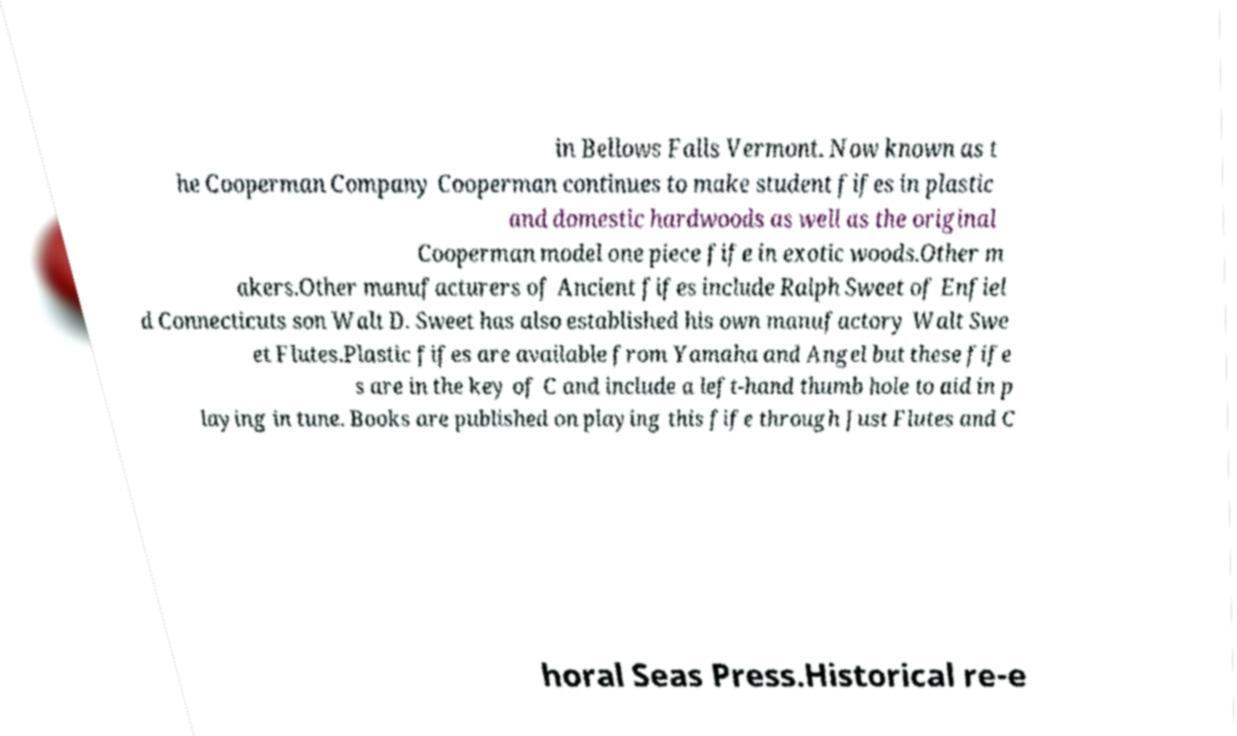What messages or text are displayed in this image? I need them in a readable, typed format. in Bellows Falls Vermont. Now known as t he Cooperman Company Cooperman continues to make student fifes in plastic and domestic hardwoods as well as the original Cooperman model one piece fife in exotic woods.Other m akers.Other manufacturers of Ancient fifes include Ralph Sweet of Enfiel d Connecticuts son Walt D. Sweet has also established his own manufactory Walt Swe et Flutes.Plastic fifes are available from Yamaha and Angel but these fife s are in the key of C and include a left-hand thumb hole to aid in p laying in tune. Books are published on playing this fife through Just Flutes and C horal Seas Press.Historical re-e 